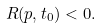Convert formula to latex. <formula><loc_0><loc_0><loc_500><loc_500>R ( p , t _ { 0 } ) < 0 .</formula> 